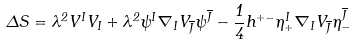<formula> <loc_0><loc_0><loc_500><loc_500>\Delta S = \lambda ^ { 2 } V ^ { I } V _ { I } + \lambda ^ { 2 } \psi ^ { I } \nabla _ { I } V _ { \overline { J } } \psi ^ { \overline { J } } - \frac { 1 } { 4 } h ^ { + - } \eta _ { + } ^ { I } \nabla _ { I } V _ { \overline { J } } \eta _ { - } ^ { \overline { J } }</formula> 